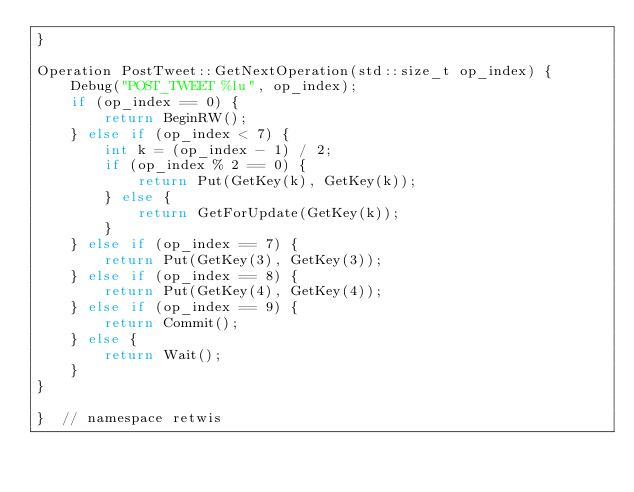Convert code to text. <code><loc_0><loc_0><loc_500><loc_500><_C++_>}

Operation PostTweet::GetNextOperation(std::size_t op_index) {
    Debug("POST_TWEET %lu", op_index);
    if (op_index == 0) {
        return BeginRW();
    } else if (op_index < 7) {
        int k = (op_index - 1) / 2;
        if (op_index % 2 == 0) {
            return Put(GetKey(k), GetKey(k));
        } else {
            return GetForUpdate(GetKey(k));
        }
    } else if (op_index == 7) {
        return Put(GetKey(3), GetKey(3));
    } else if (op_index == 8) {
        return Put(GetKey(4), GetKey(4));
    } else if (op_index == 9) {
        return Commit();
    } else {
        return Wait();
    }
}

}  // namespace retwis
</code> 